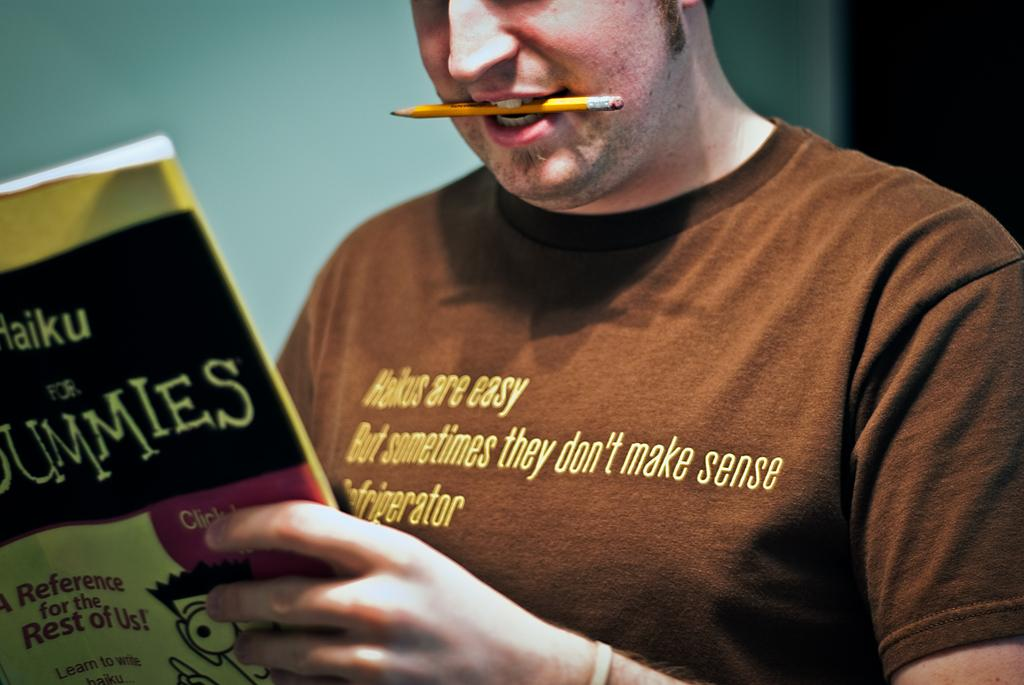<image>
Offer a succinct explanation of the picture presented. A man has a pencil in his mouth and is reading a book called Haiku for Dummies. 